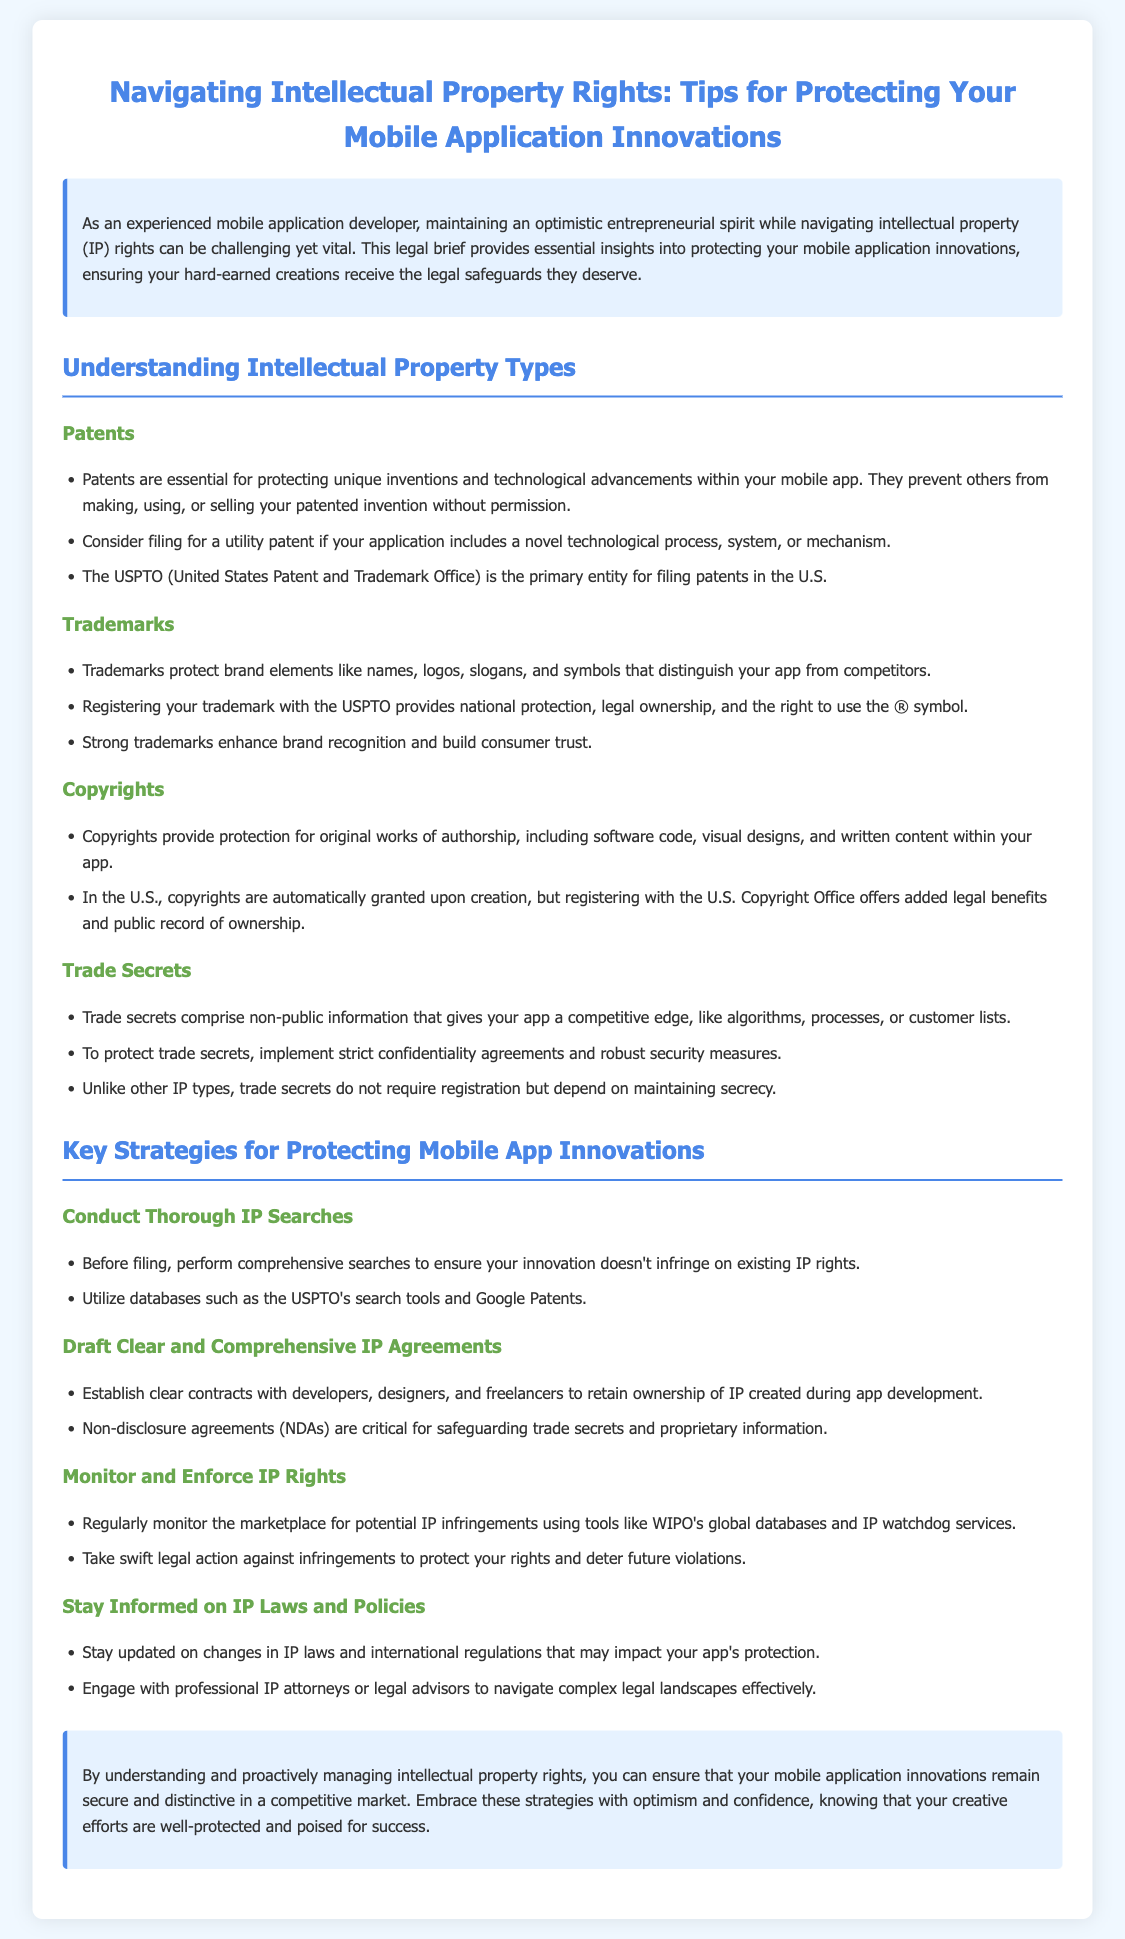What is the main focus of the legal brief? The legal brief focuses on providing insights into protecting mobile application innovations under intellectual property rights.
Answer: Protecting mobile application innovations What type of patent is suggested for novel technological processes? The document suggests filing for a utility patent for novel technological processes, systems, or mechanisms.
Answer: Utility patent Which office is primarily responsible for patent filings in the U.S.? The primary entity for filing patents in the U.S. is the USPTO (United States Patent and Trademark Office).
Answer: USPTO What should developers implement to protect trade secrets? Developers should implement strict confidentiality agreements and robust security measures to protect trade secrets.
Answer: Confidentiality agreements What is emphasized in monitoring and enforcing IP rights? The brief emphasizes regularly monitoring the marketplace for potential IP infringements and taking swift legal action against them.
Answer: Regular monitoring of the marketplace What legal tool is critical for safeguarding trade secrets? Non-disclosure agreements (NDAs) are critical for safeguarding trade secrets and proprietary information.
Answer: Non-disclosure agreements How can one ensure their IP doesn't infringe existing rights? Performing comprehensive searches before filing can help ensure new innovations don't infringe on existing IP rights.
Answer: Comprehensive searches What should developers do to stay informed on IP laws? Developers should engage with professional IP attorneys or legal advisors to stay informed on changes in IP laws and policies.
Answer: Engage with professional IP attorneys 